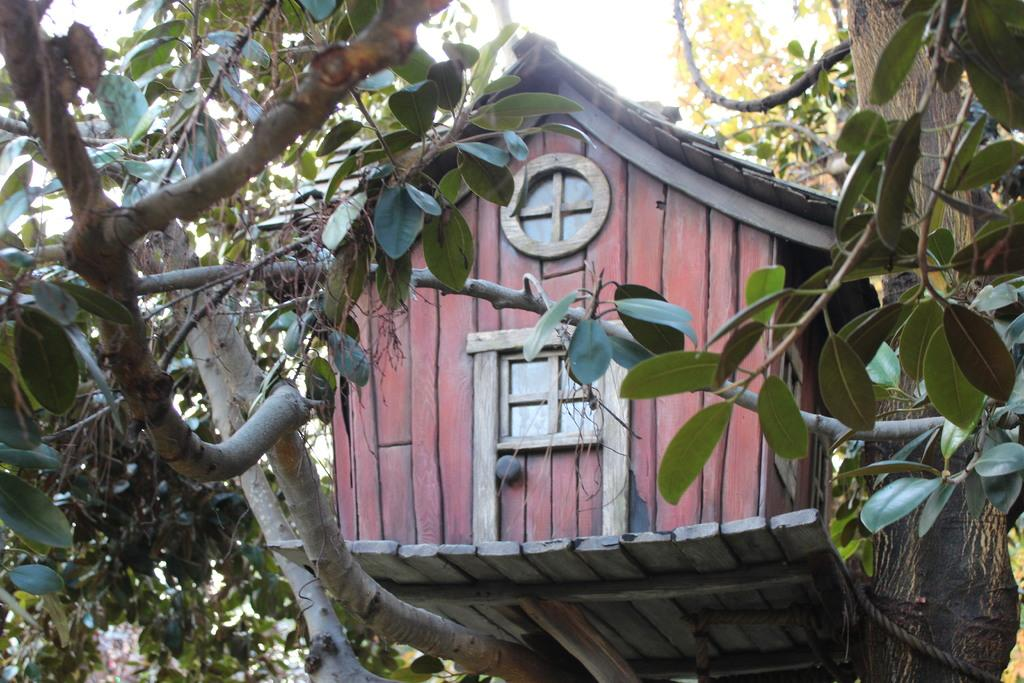What is located in the foreground of the image? There is a tree and a house in the foreground of the image. What can be seen at the top of the image? The sky is visible at the top of the image. What type of cream is being sold in the store in the image? There is no store present in the image, so it is not possible to determine what type of cream might be sold. 